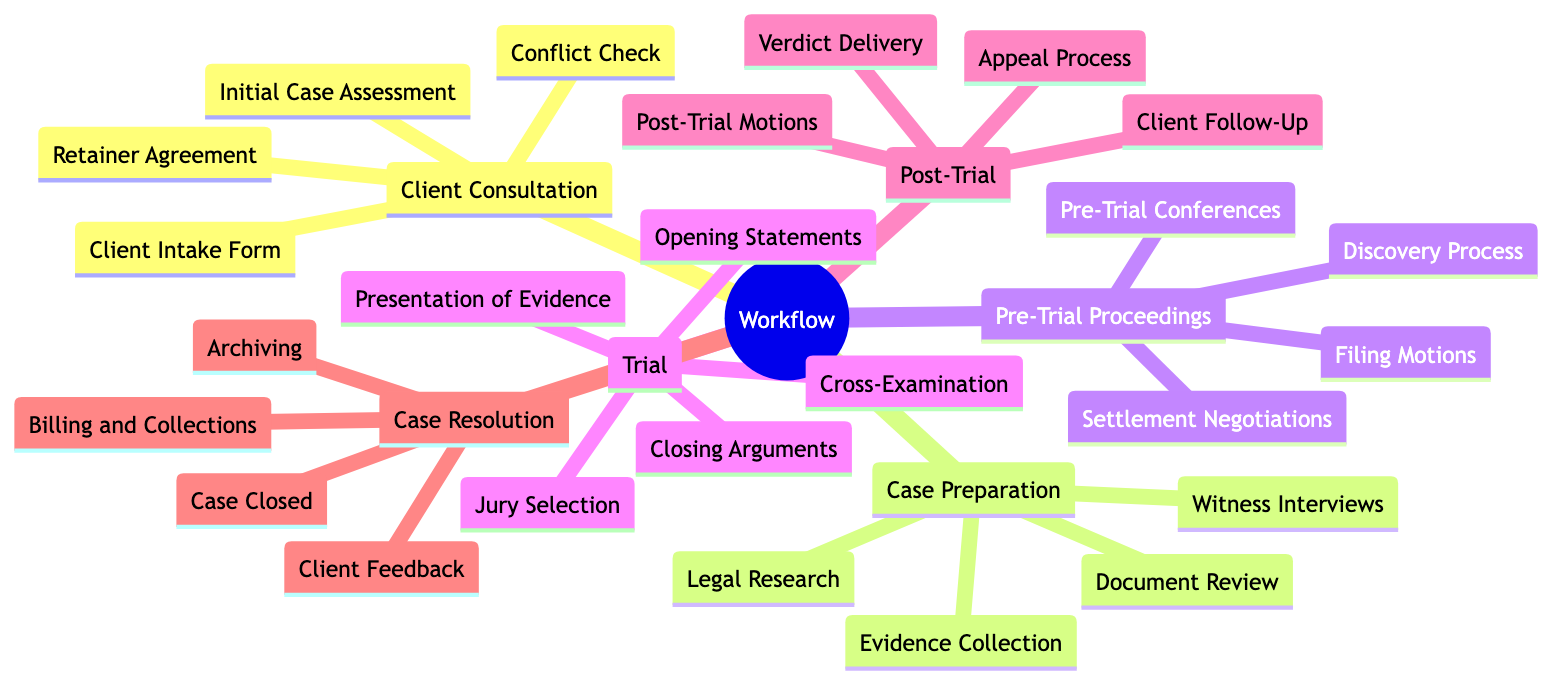What is the first element in the workflow? The first element in the workflow is identified at the top of the diagram as "Client Consultation." It represents the starting point of the entire process where initial meetings take place.
Answer: Client Consultation How many sub-elements are in "Trial"? The "Trial" node has five sub-elements listed below it: Jury Selection, Opening Statements, Presentation of Evidence, Cross-Examination, and Closing Arguments. Therefore, by counting these, we find the total is five.
Answer: 5 What follows "Pre-Trial Proceedings" in the workflow? The node that directly follows "Pre-Trial Proceedings" in the diagram is "Trial." The structure indicates a sequential flow from one step to the next.
Answer: Trial List one of the sub-elements of "Case Preparation." The sub-elements of "Case Preparation" include Document Review, Evidence Collection, Witness Interviews, and Legal Research. Any of these can be a valid answer. For example, choosing "Document Review" will suffice, as it directly corresponds to the diagram content.
Answer: Document Review Which element comes after "Client Follow-Up"? "Client Follow-Up" is a sub-element of "Post-Trial," and it leads into the next major phase, which is "Case Resolution." This indicates that after addressing client follow-up, the process continues toward case resolution.
Answer: Case Resolution How many total sub-elements does "Post-Trial" contain? The "Post-Trial" node has four sub-elements listed: Verdict Delivery, Post-Trial Motions, Appeal Process, and Client Follow-Up. By counting these, we find that "Post-Trial" contains four total sub-elements.
Answer: 4 What is the final step in the workflow? The final step in the workflow is indicated by the last sub-element under "Case Resolution," which is "Archiving." This signifies the completion of all processes related to the case.
Answer: Archiving Which two elements are directly connected? A direct connection can be established between "Case Preparation" and "Pre-Trial Proceedings" as they are sequentially adjacent in the diagram. This shows their relationship in the workflow.
Answer: Case Preparation and Pre-Trial Proceedings Which node includes "Settlement Negotiations"? "Settlement Negotiations" is a sub-element of the "Pre-Trial Proceedings" node. This placement shows its role within that stage of the workflow.
Answer: Pre-Trial Proceedings 